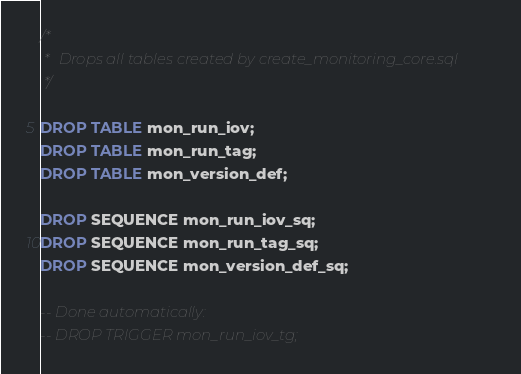Convert code to text. <code><loc_0><loc_0><loc_500><loc_500><_SQL_>/*
 *  Drops all tables created by create_monitoring_core.sql
 */

DROP TABLE mon_run_iov;
DROP TABLE mon_run_tag;
DROP TABLE mon_version_def;

DROP SEQUENCE mon_run_iov_sq;
DROP SEQUENCE mon_run_tag_sq;
DROP SEQUENCE mon_version_def_sq;

-- Done automatically:
-- DROP TRIGGER mon_run_iov_tg;
</code> 